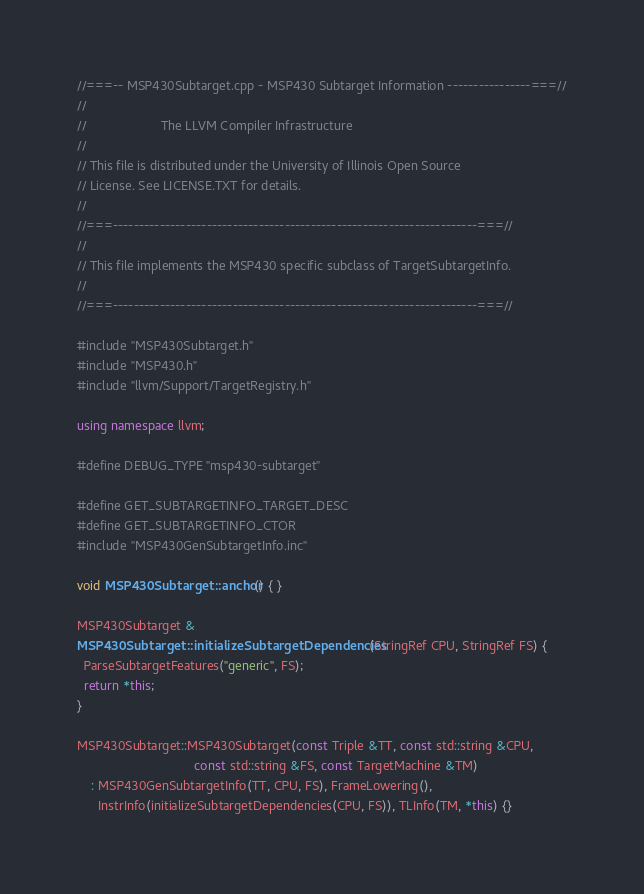<code> <loc_0><loc_0><loc_500><loc_500><_C++_>//===-- MSP430Subtarget.cpp - MSP430 Subtarget Information ----------------===//
//
//                     The LLVM Compiler Infrastructure
//
// This file is distributed under the University of Illinois Open Source
// License. See LICENSE.TXT for details.
//
//===----------------------------------------------------------------------===//
//
// This file implements the MSP430 specific subclass of TargetSubtargetInfo.
//
//===----------------------------------------------------------------------===//

#include "MSP430Subtarget.h"
#include "MSP430.h"
#include "llvm/Support/TargetRegistry.h"

using namespace llvm;

#define DEBUG_TYPE "msp430-subtarget"

#define GET_SUBTARGETINFO_TARGET_DESC
#define GET_SUBTARGETINFO_CTOR
#include "MSP430GenSubtargetInfo.inc"

void MSP430Subtarget::anchor() { }

MSP430Subtarget &
MSP430Subtarget::initializeSubtargetDependencies(StringRef CPU, StringRef FS) {
  ParseSubtargetFeatures("generic", FS);
  return *this;
}

MSP430Subtarget::MSP430Subtarget(const Triple &TT, const std::string &CPU,
                                 const std::string &FS, const TargetMachine &TM)
    : MSP430GenSubtargetInfo(TT, CPU, FS), FrameLowering(),
      InstrInfo(initializeSubtargetDependencies(CPU, FS)), TLInfo(TM, *this) {}
</code> 